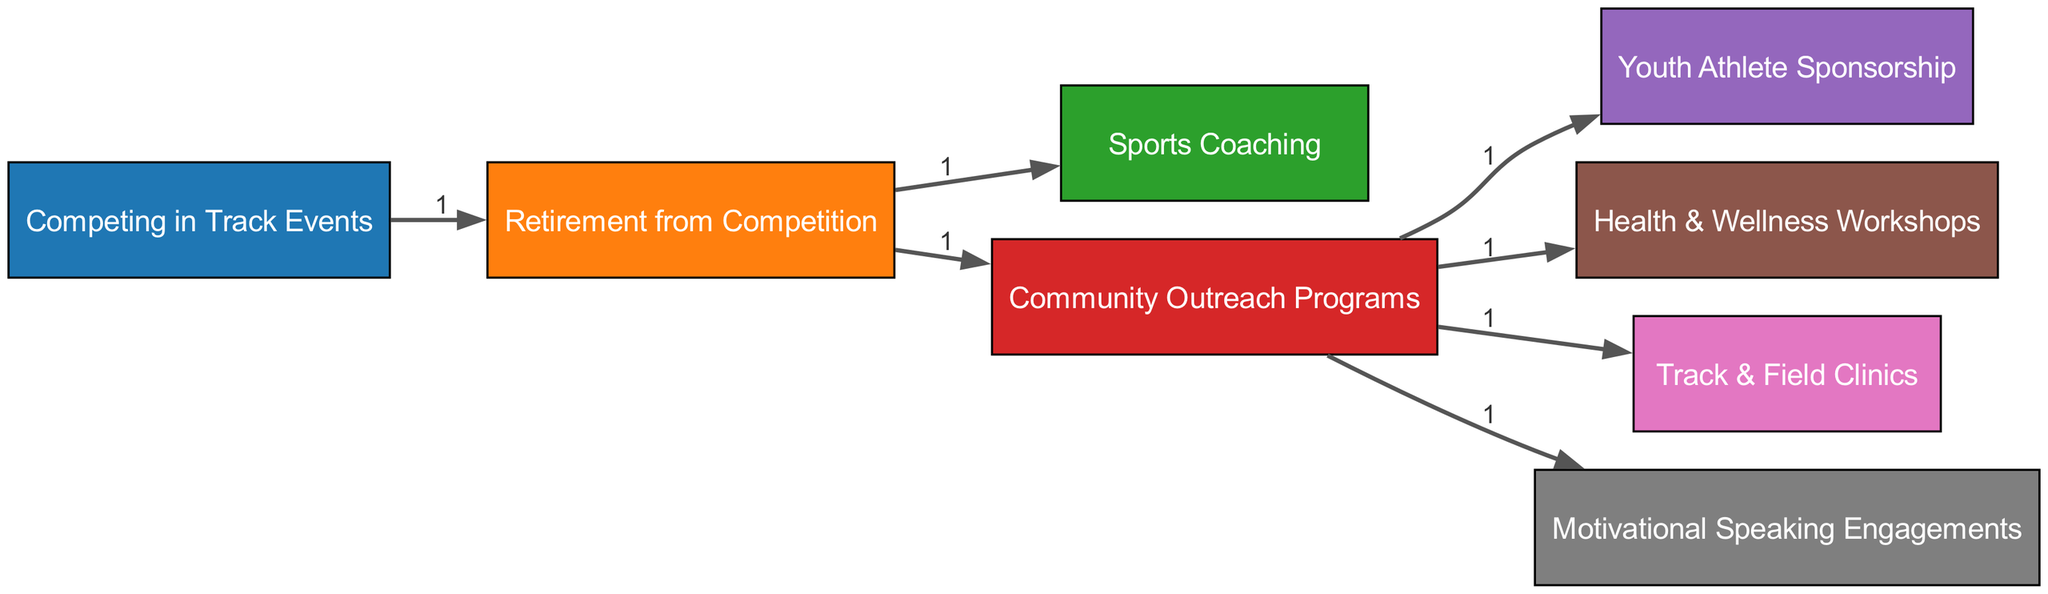What is the initial node in the diagram? The initial node, representing the start of the retired sprinter's journey, is "Competing in Track Events." Since the diagram begins with this node, it indicates the starting point of the journey.
Answer: Competing in Track Events How many total nodes are there in the diagram? By counting all the unique nodes represented in the diagram, we find there are eight nodes in total, which include all stages of the retired sprinter's journey.
Answer: 8 What is the relationship between "Retirement from Competition" and "Sports Coaching"? The relationship is direct; "Retirement from Competition" leads to "Sports Coaching" as one of the paths the retired sprinter can take. The link indicates that after retirement, they can engage in coaching.
Answer: Direct How many outreach programs are directly linked to "Community Outreach Programs"? There are four outreach programs linked directly to "Community Outreach Programs," specifically "Youth Athlete Sponsorship," "Health & Wellness Workshops," "Track & Field Clinics," and "Motivational Speaking Engagements."
Answer: 4 Which node has the highest number of outgoing connections? The node with the highest number of outgoing connections is "Community Outreach Programs," which connects to four different initiatives, illustrating the sprinter's focus on diverse outreach efforts post-retirement.
Answer: Community Outreach Programs What does the thickness of the links represent in the diagram? The thickness of the links represents the value of the connection, indicating the quantitative transition of effort or resources between nodes. However, in this specific diagram, each link has the same value of 1, so they all appear equally thick.
Answer: Value of connection What is the final outcome represented in the diagram? The final outcome represented in the diagram is the various initiatives the retired sprinter engages in, primarily focusing on community outreach after their athletic career, which underscores their ongoing impact.
Answer: Community Outreach Programs Which two nodes represent activities occurring after retirement? The activities that occur after retirement are represented by "Sports Coaching" and "Community Outreach Programs," indicating the sprinter's transition from competitive athletics to mentoring and outreach efforts.
Answer: Sports Coaching and Community Outreach Programs How does the journey from competing to community outreach illustrate the sprinter's legacy? The journey shows a transition from personal competition to serving and inspiring others in the community, emphasizing how the sprinter invests their knowledge and experience in fostering growth among youth athletes and health initiatives.
Answer: Inspiring others 